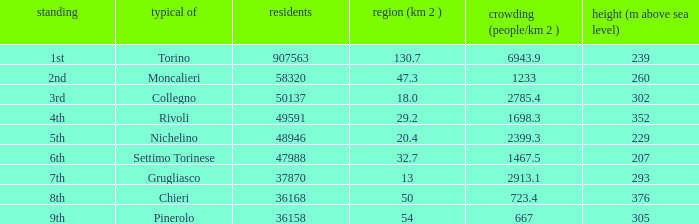How may population figures are given for Settimo Torinese 1.0. 